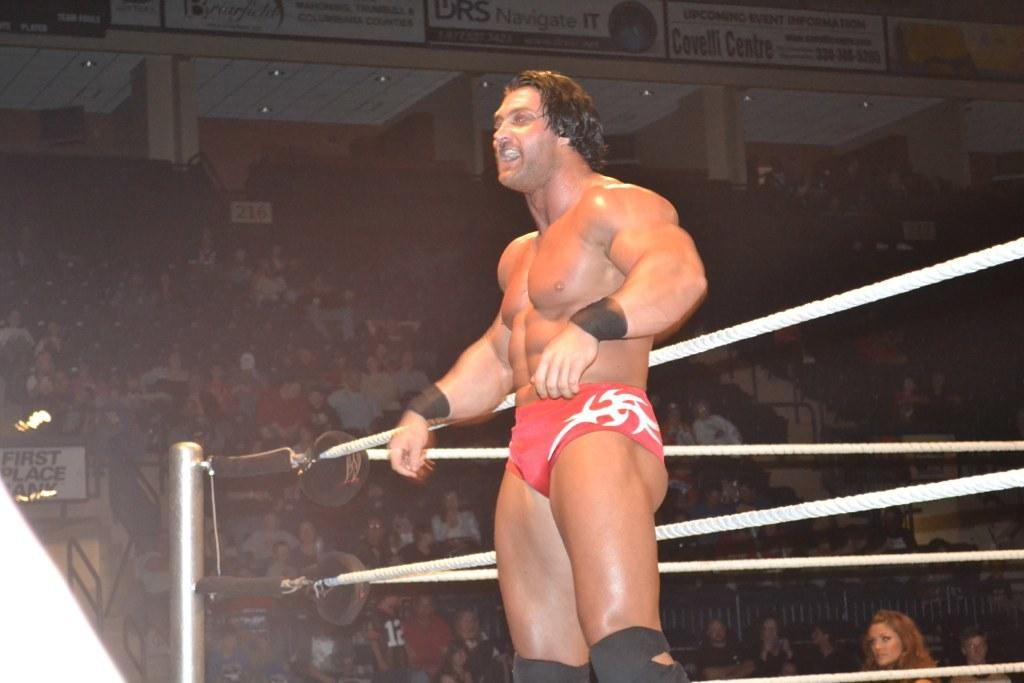Provide a one-sentence caption for the provided image. A muscular man stands out side of a boxing ring at a packed event put on by First Place Bank. 